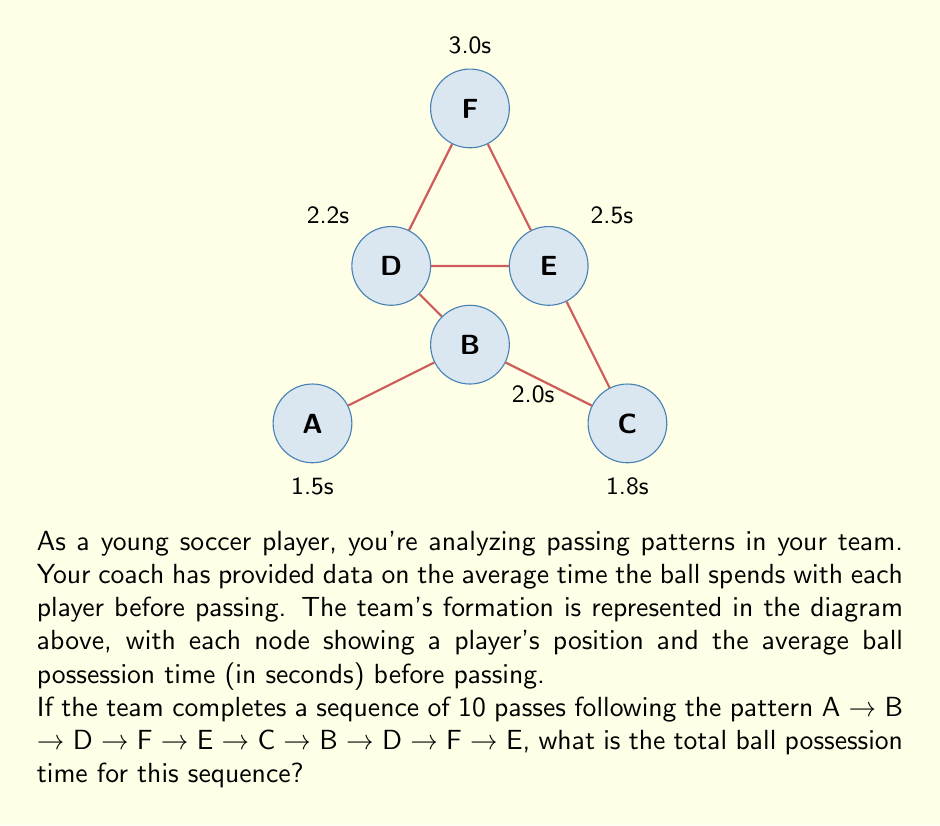Can you solve this math problem? To solve this problem, we need to sum up the ball possession times for each player in the given sequence. Let's break it down step by step:

1) First, let's list out the sequence and the corresponding possession times:
   A (1.5s) → B (2.0s) → D (2.2s) → F (3.0s) → E (2.5s) → 
   C (1.8s) → B (2.0s) → D (2.2s) → F (3.0s) → E (2.5s)

2) Now, let's add up these times:
   $$1.5 + 2.0 + 2.2 + 3.0 + 2.5 + 1.8 + 2.0 + 2.2 + 3.0 + 2.5$$

3) We can group similar terms to make the calculation easier:
   $$(1.5) + (2.0 + 2.0) + (2.2 + 2.2) + (3.0 + 3.0) + (2.5 + 2.5) + (1.8)$$

4) Simplify:
   $$1.5 + 4.0 + 4.4 + 6.0 + 5.0 + 1.8$$

5) Sum up:
   $$22.7$$

Therefore, the total ball possession time for this sequence of 10 passes is 22.7 seconds.
Answer: 22.7 seconds 